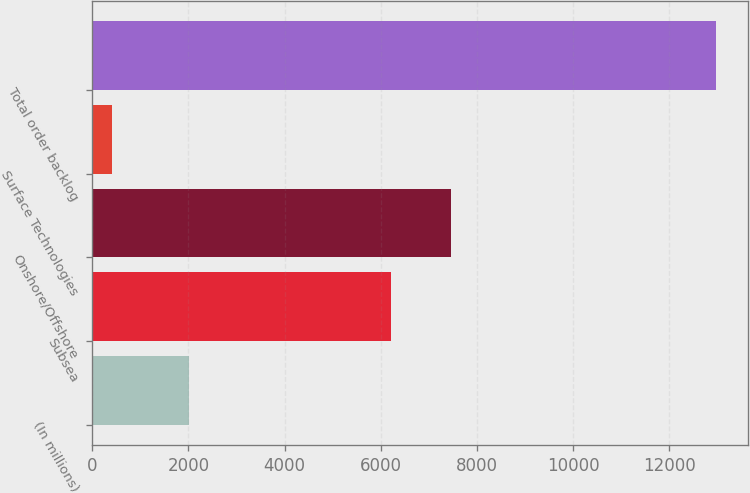Convert chart to OTSL. <chart><loc_0><loc_0><loc_500><loc_500><bar_chart><fcel>(In millions)<fcel>Subsea<fcel>Onshore/Offshore<fcel>Surface Technologies<fcel>Total order backlog<nl><fcel>2017<fcel>6203.9<fcel>7461.2<fcel>409.8<fcel>12982.8<nl></chart> 